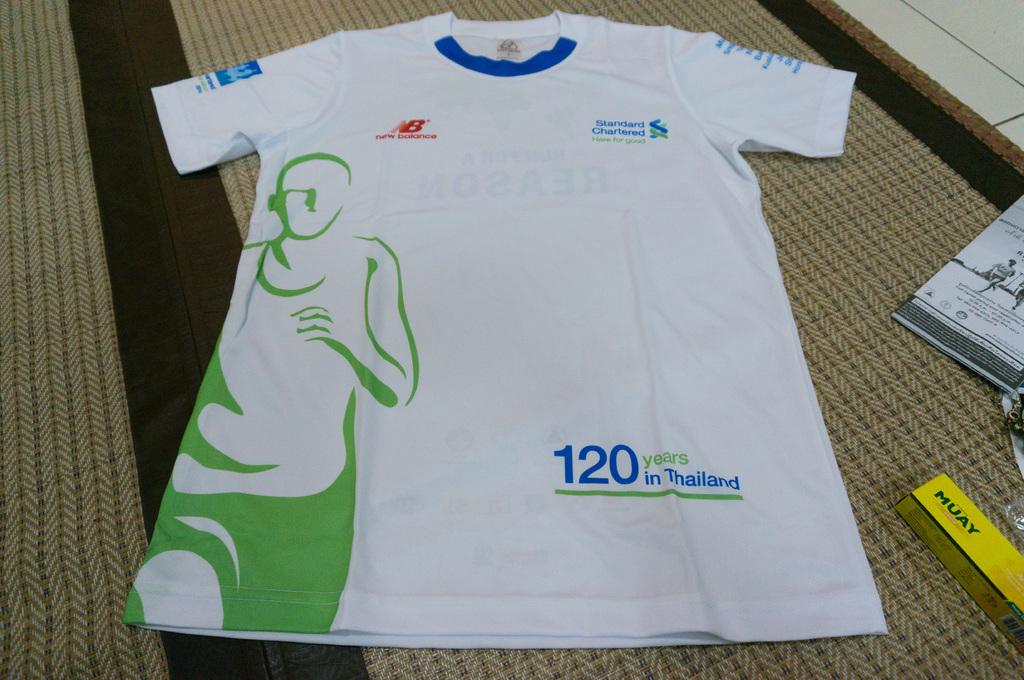What is the number displayed?
Your answer should be compact. 120. 